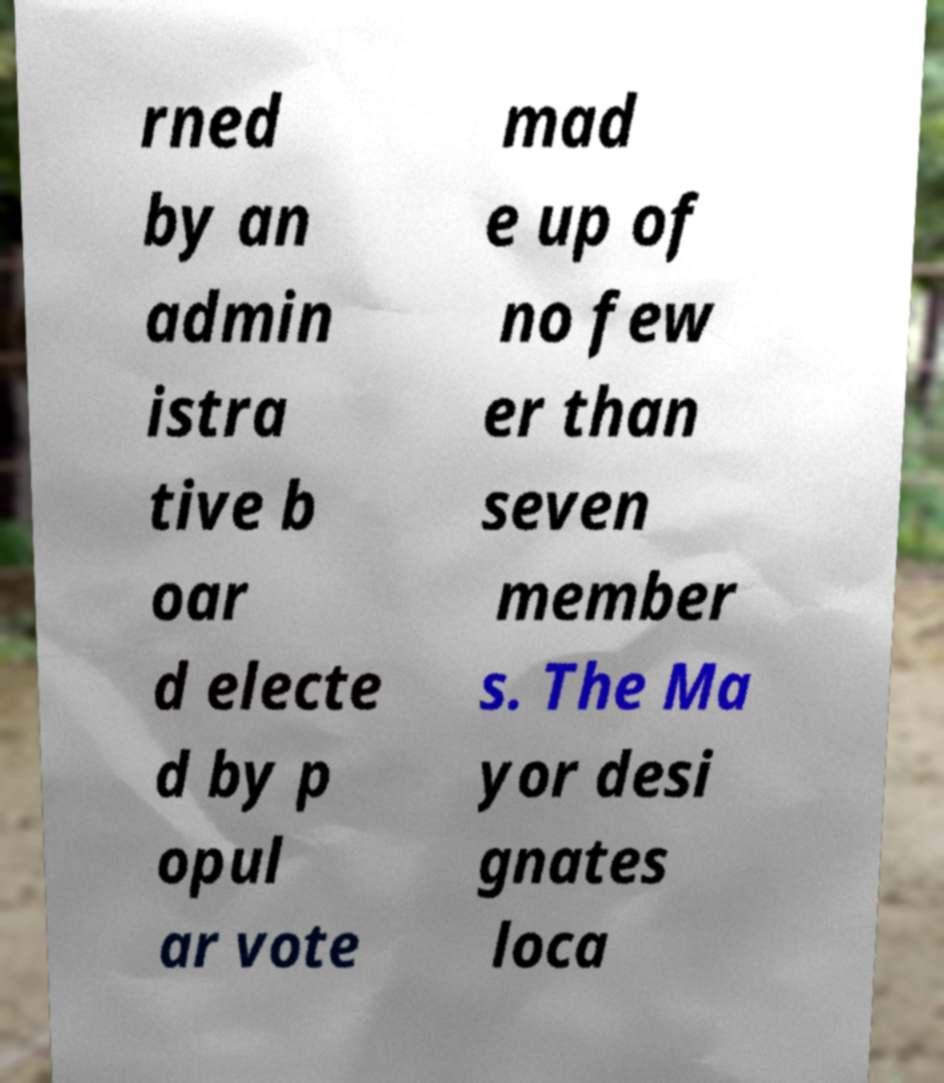Can you read and provide the text displayed in the image?This photo seems to have some interesting text. Can you extract and type it out for me? rned by an admin istra tive b oar d electe d by p opul ar vote mad e up of no few er than seven member s. The Ma yor desi gnates loca 